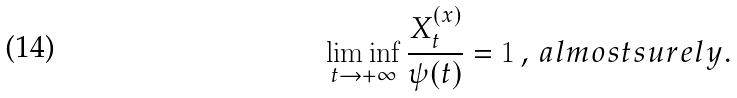Convert formula to latex. <formula><loc_0><loc_0><loc_500><loc_500>\liminf _ { t \rightarrow + \infty } \frac { X ^ { ( x ) } _ { t } } { \psi ( t ) } = 1 \, , \, a l m o s t s u r e l y .</formula> 